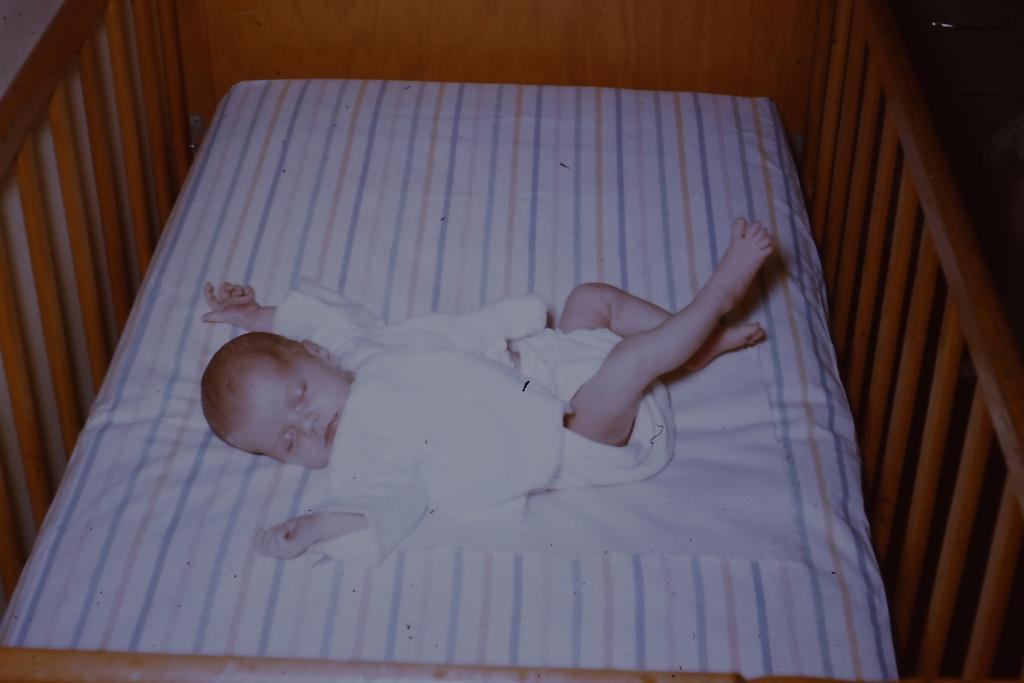What is the main subject of the image? The main subject of the image is a child. What is the child's position in the image? The child is lying in a cradle. What type of plantation can be seen in the background of the image? There is no plantation visible in the image; it only features a child lying in a cradle. What sound can be heard coming from the playground in the image? There is no playground or sound present in the image; it only features a child lying in a cradle. 